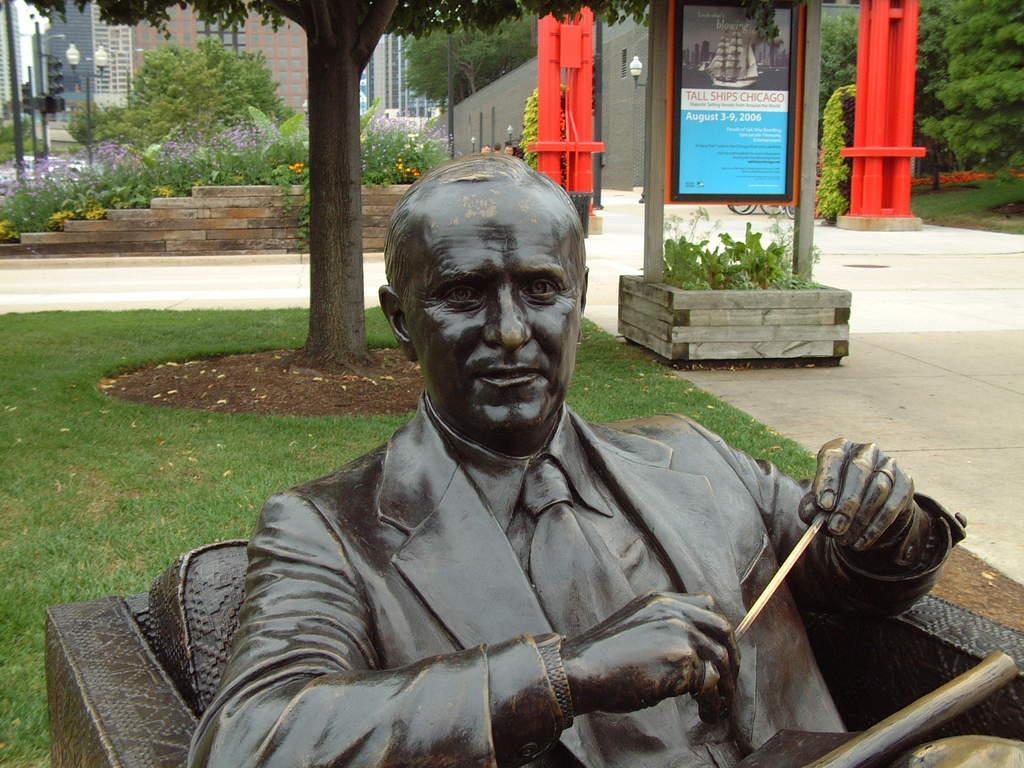How would you summarize this image in a sentence or two? We can see a man sculpture,behind this sculpture we can see grass. We can see board and plants. Background we can see buildings,lights on poles,plants and trees. 